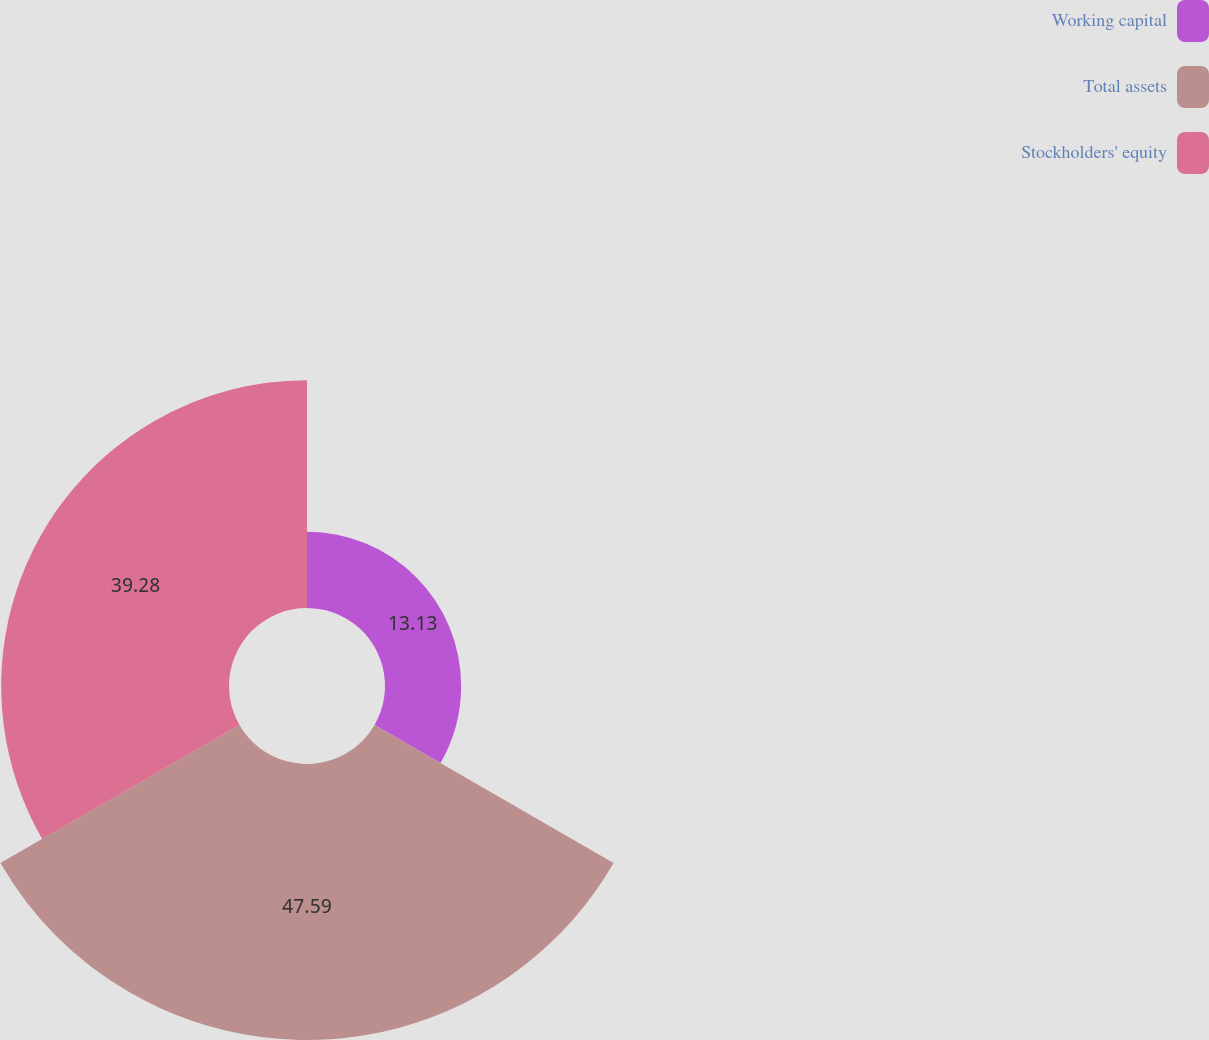Convert chart to OTSL. <chart><loc_0><loc_0><loc_500><loc_500><pie_chart><fcel>Working capital<fcel>Total assets<fcel>Stockholders' equity<nl><fcel>13.13%<fcel>47.59%<fcel>39.28%<nl></chart> 